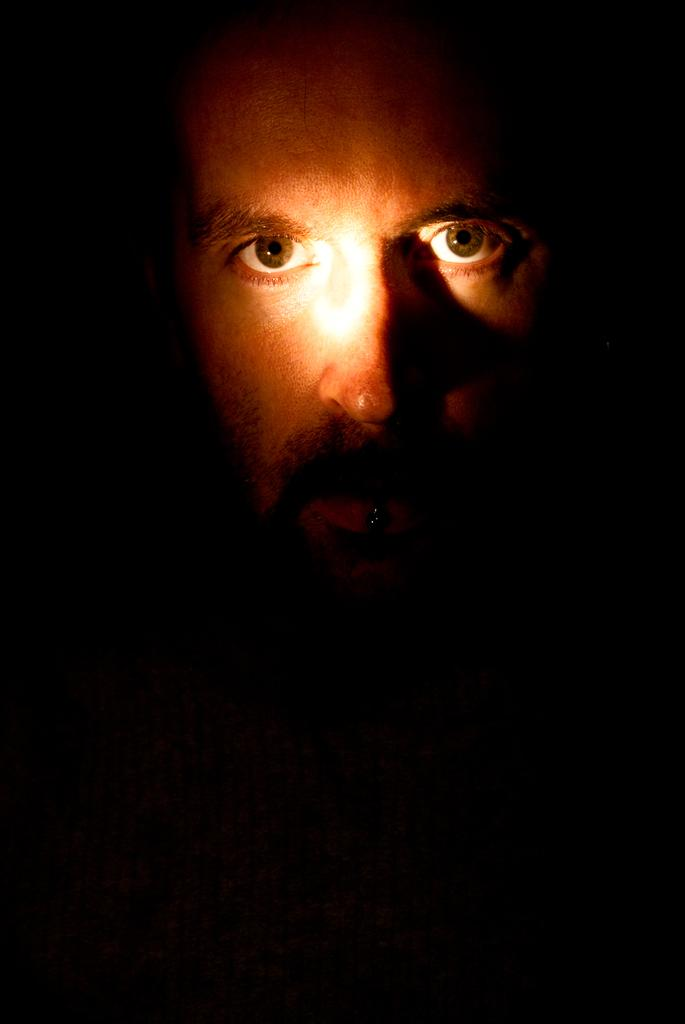What is the main subject of the image? There is a person's face in the image. What can be observed about the background of the image? The background of the image is dark in color. What type of can is visible in the image? There is no can present in the image; it features a person's face with a dark background. What kind of trousers is the person wearing in the image? The image only shows a person's face, so it is not possible to determine what type of trousers they might be wearing. 